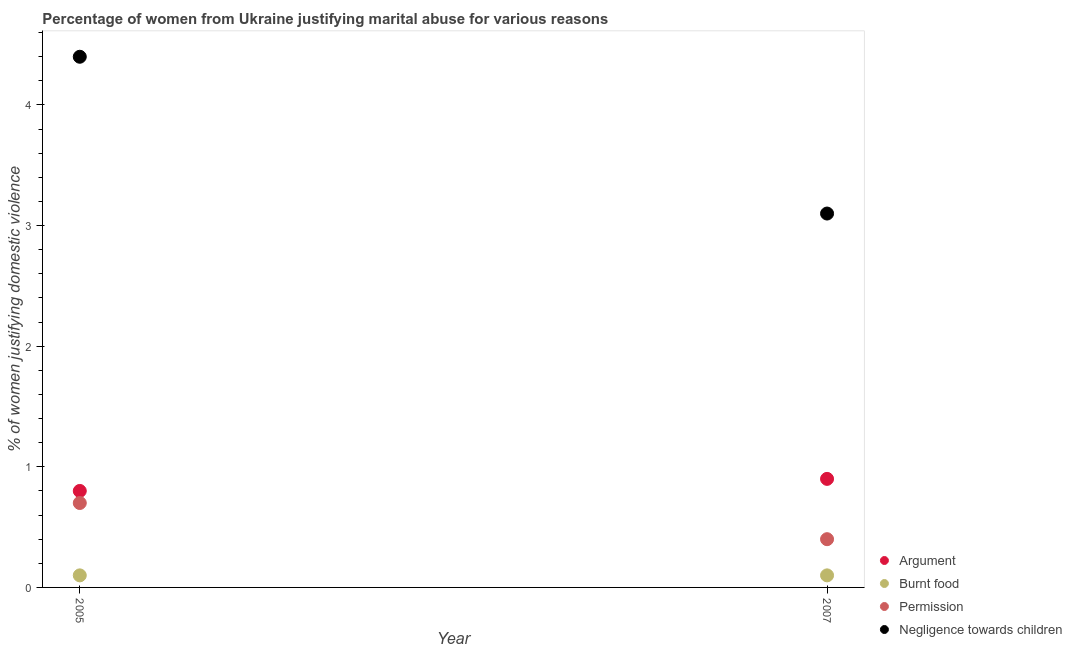Is the number of dotlines equal to the number of legend labels?
Ensure brevity in your answer.  Yes. Across all years, what is the maximum percentage of women justifying abuse for burning food?
Keep it short and to the point. 0.1. Across all years, what is the minimum percentage of women justifying abuse for showing negligence towards children?
Your answer should be very brief. 3.1. In which year was the percentage of women justifying abuse for showing negligence towards children maximum?
Provide a succinct answer. 2005. In which year was the percentage of women justifying abuse for going without permission minimum?
Offer a very short reply. 2007. What is the total percentage of women justifying abuse in the case of an argument in the graph?
Make the answer very short. 1.7. What is the difference between the percentage of women justifying abuse for going without permission in 2005 and that in 2007?
Your answer should be very brief. 0.3. What is the difference between the percentage of women justifying abuse for showing negligence towards children in 2007 and the percentage of women justifying abuse for going without permission in 2005?
Make the answer very short. 2.4. What is the average percentage of women justifying abuse for going without permission per year?
Give a very brief answer. 0.55. What is the ratio of the percentage of women justifying abuse for burning food in 2005 to that in 2007?
Give a very brief answer. 1. Is the percentage of women justifying abuse for showing negligence towards children in 2005 less than that in 2007?
Provide a succinct answer. No. Is it the case that in every year, the sum of the percentage of women justifying abuse for showing negligence towards children and percentage of women justifying abuse for burning food is greater than the sum of percentage of women justifying abuse in the case of an argument and percentage of women justifying abuse for going without permission?
Make the answer very short. No. Does the percentage of women justifying abuse for burning food monotonically increase over the years?
Your response must be concise. No. Is the percentage of women justifying abuse for burning food strictly greater than the percentage of women justifying abuse for going without permission over the years?
Your answer should be very brief. No. What is the difference between two consecutive major ticks on the Y-axis?
Offer a terse response. 1. Does the graph contain grids?
Provide a short and direct response. No. How many legend labels are there?
Your answer should be very brief. 4. What is the title of the graph?
Offer a very short reply. Percentage of women from Ukraine justifying marital abuse for various reasons. Does "Taxes on income" appear as one of the legend labels in the graph?
Your response must be concise. No. What is the label or title of the Y-axis?
Provide a succinct answer. % of women justifying domestic violence. What is the % of women justifying domestic violence of Permission in 2005?
Provide a short and direct response. 0.7. What is the % of women justifying domestic violence of Argument in 2007?
Keep it short and to the point. 0.9. What is the % of women justifying domestic violence in Burnt food in 2007?
Provide a short and direct response. 0.1. What is the % of women justifying domestic violence in Permission in 2007?
Provide a short and direct response. 0.4. What is the % of women justifying domestic violence in Negligence towards children in 2007?
Offer a very short reply. 3.1. Across all years, what is the maximum % of women justifying domestic violence of Argument?
Your response must be concise. 0.9. Across all years, what is the maximum % of women justifying domestic violence in Burnt food?
Your answer should be very brief. 0.1. Across all years, what is the minimum % of women justifying domestic violence of Argument?
Make the answer very short. 0.8. Across all years, what is the minimum % of women justifying domestic violence in Burnt food?
Give a very brief answer. 0.1. Across all years, what is the minimum % of women justifying domestic violence in Permission?
Provide a short and direct response. 0.4. Across all years, what is the minimum % of women justifying domestic violence of Negligence towards children?
Ensure brevity in your answer.  3.1. What is the total % of women justifying domestic violence of Argument in the graph?
Your answer should be very brief. 1.7. What is the total % of women justifying domestic violence in Permission in the graph?
Your answer should be very brief. 1.1. What is the total % of women justifying domestic violence of Negligence towards children in the graph?
Your answer should be compact. 7.5. What is the difference between the % of women justifying domestic violence of Burnt food in 2005 and that in 2007?
Offer a very short reply. 0. What is the difference between the % of women justifying domestic violence of Argument in 2005 and the % of women justifying domestic violence of Negligence towards children in 2007?
Your answer should be compact. -2.3. What is the difference between the % of women justifying domestic violence in Burnt food in 2005 and the % of women justifying domestic violence in Permission in 2007?
Keep it short and to the point. -0.3. What is the difference between the % of women justifying domestic violence in Burnt food in 2005 and the % of women justifying domestic violence in Negligence towards children in 2007?
Give a very brief answer. -3. What is the average % of women justifying domestic violence in Burnt food per year?
Keep it short and to the point. 0.1. What is the average % of women justifying domestic violence in Permission per year?
Provide a short and direct response. 0.55. What is the average % of women justifying domestic violence in Negligence towards children per year?
Keep it short and to the point. 3.75. In the year 2005, what is the difference between the % of women justifying domestic violence of Argument and % of women justifying domestic violence of Negligence towards children?
Give a very brief answer. -3.6. In the year 2005, what is the difference between the % of women justifying domestic violence in Permission and % of women justifying domestic violence in Negligence towards children?
Offer a very short reply. -3.7. In the year 2007, what is the difference between the % of women justifying domestic violence of Argument and % of women justifying domestic violence of Burnt food?
Give a very brief answer. 0.8. In the year 2007, what is the difference between the % of women justifying domestic violence in Argument and % of women justifying domestic violence in Permission?
Provide a short and direct response. 0.5. In the year 2007, what is the difference between the % of women justifying domestic violence of Burnt food and % of women justifying domestic violence of Permission?
Your answer should be very brief. -0.3. In the year 2007, what is the difference between the % of women justifying domestic violence in Permission and % of women justifying domestic violence in Negligence towards children?
Your response must be concise. -2.7. What is the ratio of the % of women justifying domestic violence in Negligence towards children in 2005 to that in 2007?
Offer a terse response. 1.42. What is the difference between the highest and the second highest % of women justifying domestic violence in Burnt food?
Offer a very short reply. 0. What is the difference between the highest and the lowest % of women justifying domestic violence of Argument?
Your response must be concise. 0.1. What is the difference between the highest and the lowest % of women justifying domestic violence in Permission?
Give a very brief answer. 0.3. What is the difference between the highest and the lowest % of women justifying domestic violence of Negligence towards children?
Offer a terse response. 1.3. 